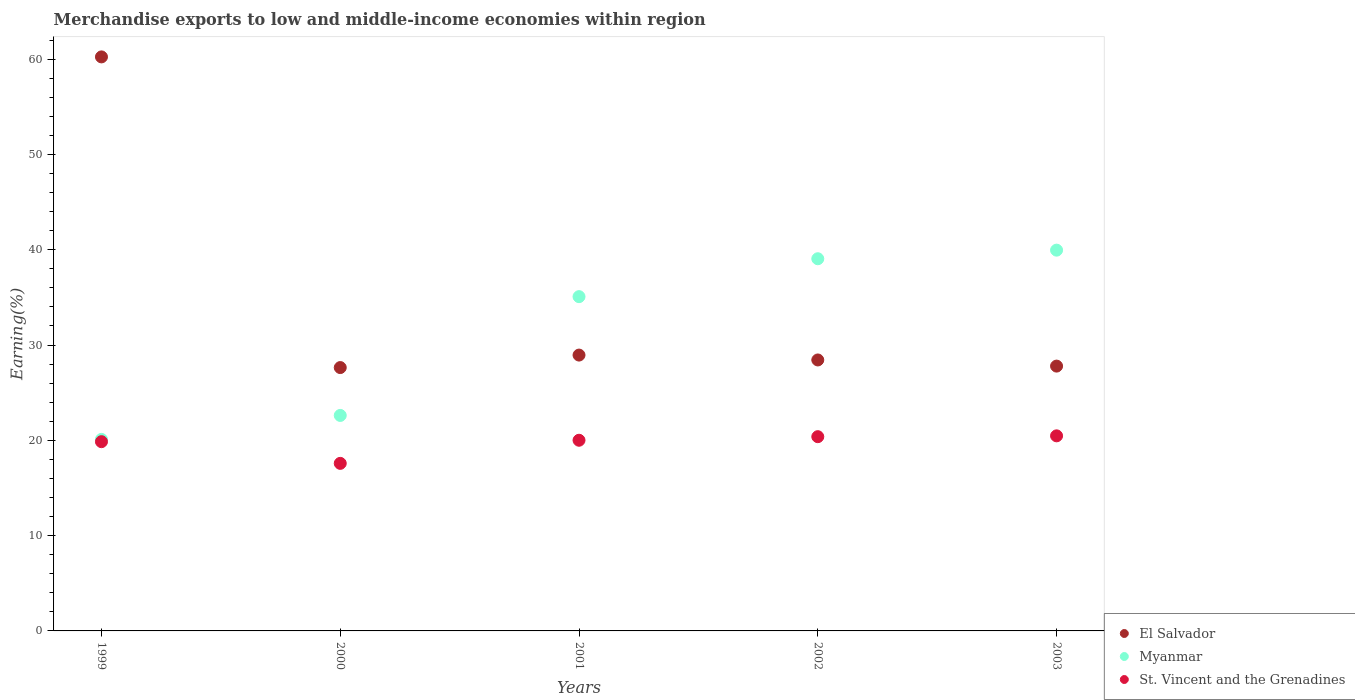Is the number of dotlines equal to the number of legend labels?
Give a very brief answer. Yes. What is the percentage of amount earned from merchandise exports in El Salvador in 1999?
Make the answer very short. 60.24. Across all years, what is the maximum percentage of amount earned from merchandise exports in St. Vincent and the Grenadines?
Offer a terse response. 20.47. Across all years, what is the minimum percentage of amount earned from merchandise exports in Myanmar?
Provide a succinct answer. 20.1. In which year was the percentage of amount earned from merchandise exports in St. Vincent and the Grenadines maximum?
Offer a very short reply. 2003. In which year was the percentage of amount earned from merchandise exports in El Salvador minimum?
Your answer should be compact. 2000. What is the total percentage of amount earned from merchandise exports in El Salvador in the graph?
Your answer should be very brief. 173.04. What is the difference between the percentage of amount earned from merchandise exports in St. Vincent and the Grenadines in 2001 and that in 2003?
Provide a short and direct response. -0.46. What is the difference between the percentage of amount earned from merchandise exports in Myanmar in 2002 and the percentage of amount earned from merchandise exports in St. Vincent and the Grenadines in 1999?
Keep it short and to the point. 19.2. What is the average percentage of amount earned from merchandise exports in Myanmar per year?
Your response must be concise. 31.36. In the year 2002, what is the difference between the percentage of amount earned from merchandise exports in St. Vincent and the Grenadines and percentage of amount earned from merchandise exports in El Salvador?
Offer a terse response. -8.05. In how many years, is the percentage of amount earned from merchandise exports in Myanmar greater than 58 %?
Offer a terse response. 0. What is the ratio of the percentage of amount earned from merchandise exports in El Salvador in 2000 to that in 2001?
Make the answer very short. 0.95. Is the percentage of amount earned from merchandise exports in El Salvador in 1999 less than that in 2002?
Provide a short and direct response. No. Is the difference between the percentage of amount earned from merchandise exports in St. Vincent and the Grenadines in 1999 and 2000 greater than the difference between the percentage of amount earned from merchandise exports in El Salvador in 1999 and 2000?
Offer a very short reply. No. What is the difference between the highest and the second highest percentage of amount earned from merchandise exports in El Salvador?
Provide a short and direct response. 31.29. What is the difference between the highest and the lowest percentage of amount earned from merchandise exports in Myanmar?
Provide a short and direct response. 19.86. In how many years, is the percentage of amount earned from merchandise exports in St. Vincent and the Grenadines greater than the average percentage of amount earned from merchandise exports in St. Vincent and the Grenadines taken over all years?
Provide a short and direct response. 4. Is the sum of the percentage of amount earned from merchandise exports in St. Vincent and the Grenadines in 1999 and 2002 greater than the maximum percentage of amount earned from merchandise exports in El Salvador across all years?
Provide a succinct answer. No. Is it the case that in every year, the sum of the percentage of amount earned from merchandise exports in Myanmar and percentage of amount earned from merchandise exports in St. Vincent and the Grenadines  is greater than the percentage of amount earned from merchandise exports in El Salvador?
Provide a short and direct response. No. Does the percentage of amount earned from merchandise exports in Myanmar monotonically increase over the years?
Ensure brevity in your answer.  Yes. Is the percentage of amount earned from merchandise exports in St. Vincent and the Grenadines strictly less than the percentage of amount earned from merchandise exports in Myanmar over the years?
Your response must be concise. Yes. How many dotlines are there?
Your answer should be very brief. 3. How many years are there in the graph?
Make the answer very short. 5. What is the difference between two consecutive major ticks on the Y-axis?
Ensure brevity in your answer.  10. Does the graph contain any zero values?
Offer a very short reply. No. How many legend labels are there?
Make the answer very short. 3. How are the legend labels stacked?
Your answer should be very brief. Vertical. What is the title of the graph?
Give a very brief answer. Merchandise exports to low and middle-income economies within region. Does "Uruguay" appear as one of the legend labels in the graph?
Your answer should be very brief. No. What is the label or title of the X-axis?
Your answer should be compact. Years. What is the label or title of the Y-axis?
Make the answer very short. Earning(%). What is the Earning(%) of El Salvador in 1999?
Provide a succinct answer. 60.24. What is the Earning(%) in Myanmar in 1999?
Offer a very short reply. 20.1. What is the Earning(%) of St. Vincent and the Grenadines in 1999?
Your response must be concise. 19.86. What is the Earning(%) of El Salvador in 2000?
Your answer should be very brief. 27.64. What is the Earning(%) in Myanmar in 2000?
Keep it short and to the point. 22.61. What is the Earning(%) of St. Vincent and the Grenadines in 2000?
Make the answer very short. 17.58. What is the Earning(%) of El Salvador in 2001?
Your answer should be very brief. 28.95. What is the Earning(%) in Myanmar in 2001?
Your response must be concise. 35.08. What is the Earning(%) of St. Vincent and the Grenadines in 2001?
Your answer should be compact. 20.01. What is the Earning(%) of El Salvador in 2002?
Your answer should be very brief. 28.43. What is the Earning(%) of Myanmar in 2002?
Your answer should be compact. 39.06. What is the Earning(%) in St. Vincent and the Grenadines in 2002?
Offer a terse response. 20.38. What is the Earning(%) of El Salvador in 2003?
Your answer should be compact. 27.79. What is the Earning(%) in Myanmar in 2003?
Make the answer very short. 39.96. What is the Earning(%) of St. Vincent and the Grenadines in 2003?
Give a very brief answer. 20.47. Across all years, what is the maximum Earning(%) of El Salvador?
Make the answer very short. 60.24. Across all years, what is the maximum Earning(%) of Myanmar?
Your response must be concise. 39.96. Across all years, what is the maximum Earning(%) of St. Vincent and the Grenadines?
Offer a terse response. 20.47. Across all years, what is the minimum Earning(%) in El Salvador?
Offer a terse response. 27.64. Across all years, what is the minimum Earning(%) of Myanmar?
Offer a terse response. 20.1. Across all years, what is the minimum Earning(%) in St. Vincent and the Grenadines?
Offer a very short reply. 17.58. What is the total Earning(%) in El Salvador in the graph?
Give a very brief answer. 173.04. What is the total Earning(%) of Myanmar in the graph?
Your answer should be very brief. 156.8. What is the total Earning(%) in St. Vincent and the Grenadines in the graph?
Keep it short and to the point. 98.3. What is the difference between the Earning(%) in El Salvador in 1999 and that in 2000?
Provide a short and direct response. 32.6. What is the difference between the Earning(%) of Myanmar in 1999 and that in 2000?
Give a very brief answer. -2.51. What is the difference between the Earning(%) in St. Vincent and the Grenadines in 1999 and that in 2000?
Provide a succinct answer. 2.27. What is the difference between the Earning(%) of El Salvador in 1999 and that in 2001?
Provide a succinct answer. 31.29. What is the difference between the Earning(%) of Myanmar in 1999 and that in 2001?
Your response must be concise. -14.98. What is the difference between the Earning(%) in St. Vincent and the Grenadines in 1999 and that in 2001?
Your response must be concise. -0.15. What is the difference between the Earning(%) in El Salvador in 1999 and that in 2002?
Offer a terse response. 31.8. What is the difference between the Earning(%) of Myanmar in 1999 and that in 2002?
Make the answer very short. -18.96. What is the difference between the Earning(%) of St. Vincent and the Grenadines in 1999 and that in 2002?
Your response must be concise. -0.53. What is the difference between the Earning(%) in El Salvador in 1999 and that in 2003?
Give a very brief answer. 32.45. What is the difference between the Earning(%) in Myanmar in 1999 and that in 2003?
Your answer should be compact. -19.86. What is the difference between the Earning(%) of St. Vincent and the Grenadines in 1999 and that in 2003?
Make the answer very short. -0.61. What is the difference between the Earning(%) in El Salvador in 2000 and that in 2001?
Ensure brevity in your answer.  -1.31. What is the difference between the Earning(%) of Myanmar in 2000 and that in 2001?
Provide a succinct answer. -12.47. What is the difference between the Earning(%) in St. Vincent and the Grenadines in 2000 and that in 2001?
Provide a succinct answer. -2.43. What is the difference between the Earning(%) of El Salvador in 2000 and that in 2002?
Give a very brief answer. -0.8. What is the difference between the Earning(%) in Myanmar in 2000 and that in 2002?
Give a very brief answer. -16.44. What is the difference between the Earning(%) in St. Vincent and the Grenadines in 2000 and that in 2002?
Keep it short and to the point. -2.8. What is the difference between the Earning(%) of El Salvador in 2000 and that in 2003?
Your answer should be very brief. -0.15. What is the difference between the Earning(%) in Myanmar in 2000 and that in 2003?
Your response must be concise. -17.34. What is the difference between the Earning(%) of St. Vincent and the Grenadines in 2000 and that in 2003?
Provide a short and direct response. -2.89. What is the difference between the Earning(%) of El Salvador in 2001 and that in 2002?
Keep it short and to the point. 0.51. What is the difference between the Earning(%) of Myanmar in 2001 and that in 2002?
Keep it short and to the point. -3.98. What is the difference between the Earning(%) in St. Vincent and the Grenadines in 2001 and that in 2002?
Offer a terse response. -0.37. What is the difference between the Earning(%) of El Salvador in 2001 and that in 2003?
Ensure brevity in your answer.  1.16. What is the difference between the Earning(%) of Myanmar in 2001 and that in 2003?
Offer a terse response. -4.88. What is the difference between the Earning(%) in St. Vincent and the Grenadines in 2001 and that in 2003?
Keep it short and to the point. -0.46. What is the difference between the Earning(%) in El Salvador in 2002 and that in 2003?
Your answer should be very brief. 0.64. What is the difference between the Earning(%) in Myanmar in 2002 and that in 2003?
Give a very brief answer. -0.9. What is the difference between the Earning(%) in St. Vincent and the Grenadines in 2002 and that in 2003?
Keep it short and to the point. -0.09. What is the difference between the Earning(%) of El Salvador in 1999 and the Earning(%) of Myanmar in 2000?
Provide a short and direct response. 37.62. What is the difference between the Earning(%) in El Salvador in 1999 and the Earning(%) in St. Vincent and the Grenadines in 2000?
Make the answer very short. 42.65. What is the difference between the Earning(%) in Myanmar in 1999 and the Earning(%) in St. Vincent and the Grenadines in 2000?
Offer a very short reply. 2.51. What is the difference between the Earning(%) of El Salvador in 1999 and the Earning(%) of Myanmar in 2001?
Ensure brevity in your answer.  25.16. What is the difference between the Earning(%) in El Salvador in 1999 and the Earning(%) in St. Vincent and the Grenadines in 2001?
Offer a terse response. 40.23. What is the difference between the Earning(%) in Myanmar in 1999 and the Earning(%) in St. Vincent and the Grenadines in 2001?
Your answer should be very brief. 0.09. What is the difference between the Earning(%) in El Salvador in 1999 and the Earning(%) in Myanmar in 2002?
Provide a short and direct response. 21.18. What is the difference between the Earning(%) of El Salvador in 1999 and the Earning(%) of St. Vincent and the Grenadines in 2002?
Your answer should be compact. 39.85. What is the difference between the Earning(%) of Myanmar in 1999 and the Earning(%) of St. Vincent and the Grenadines in 2002?
Offer a very short reply. -0.29. What is the difference between the Earning(%) of El Salvador in 1999 and the Earning(%) of Myanmar in 2003?
Provide a succinct answer. 20.28. What is the difference between the Earning(%) in El Salvador in 1999 and the Earning(%) in St. Vincent and the Grenadines in 2003?
Your response must be concise. 39.77. What is the difference between the Earning(%) in Myanmar in 1999 and the Earning(%) in St. Vincent and the Grenadines in 2003?
Give a very brief answer. -0.37. What is the difference between the Earning(%) in El Salvador in 2000 and the Earning(%) in Myanmar in 2001?
Ensure brevity in your answer.  -7.44. What is the difference between the Earning(%) of El Salvador in 2000 and the Earning(%) of St. Vincent and the Grenadines in 2001?
Give a very brief answer. 7.63. What is the difference between the Earning(%) in Myanmar in 2000 and the Earning(%) in St. Vincent and the Grenadines in 2001?
Your answer should be very brief. 2.6. What is the difference between the Earning(%) in El Salvador in 2000 and the Earning(%) in Myanmar in 2002?
Offer a terse response. -11.42. What is the difference between the Earning(%) of El Salvador in 2000 and the Earning(%) of St. Vincent and the Grenadines in 2002?
Your response must be concise. 7.25. What is the difference between the Earning(%) of Myanmar in 2000 and the Earning(%) of St. Vincent and the Grenadines in 2002?
Make the answer very short. 2.23. What is the difference between the Earning(%) in El Salvador in 2000 and the Earning(%) in Myanmar in 2003?
Make the answer very short. -12.32. What is the difference between the Earning(%) in El Salvador in 2000 and the Earning(%) in St. Vincent and the Grenadines in 2003?
Give a very brief answer. 7.16. What is the difference between the Earning(%) in Myanmar in 2000 and the Earning(%) in St. Vincent and the Grenadines in 2003?
Your response must be concise. 2.14. What is the difference between the Earning(%) in El Salvador in 2001 and the Earning(%) in Myanmar in 2002?
Your answer should be very brief. -10.11. What is the difference between the Earning(%) of El Salvador in 2001 and the Earning(%) of St. Vincent and the Grenadines in 2002?
Offer a very short reply. 8.56. What is the difference between the Earning(%) of Myanmar in 2001 and the Earning(%) of St. Vincent and the Grenadines in 2002?
Your answer should be compact. 14.69. What is the difference between the Earning(%) in El Salvador in 2001 and the Earning(%) in Myanmar in 2003?
Provide a short and direct response. -11.01. What is the difference between the Earning(%) of El Salvador in 2001 and the Earning(%) of St. Vincent and the Grenadines in 2003?
Provide a short and direct response. 8.47. What is the difference between the Earning(%) in Myanmar in 2001 and the Earning(%) in St. Vincent and the Grenadines in 2003?
Provide a succinct answer. 14.61. What is the difference between the Earning(%) in El Salvador in 2002 and the Earning(%) in Myanmar in 2003?
Provide a succinct answer. -11.52. What is the difference between the Earning(%) of El Salvador in 2002 and the Earning(%) of St. Vincent and the Grenadines in 2003?
Provide a short and direct response. 7.96. What is the difference between the Earning(%) of Myanmar in 2002 and the Earning(%) of St. Vincent and the Grenadines in 2003?
Offer a terse response. 18.58. What is the average Earning(%) of El Salvador per year?
Make the answer very short. 34.61. What is the average Earning(%) of Myanmar per year?
Make the answer very short. 31.36. What is the average Earning(%) in St. Vincent and the Grenadines per year?
Keep it short and to the point. 19.66. In the year 1999, what is the difference between the Earning(%) in El Salvador and Earning(%) in Myanmar?
Your answer should be very brief. 40.14. In the year 1999, what is the difference between the Earning(%) in El Salvador and Earning(%) in St. Vincent and the Grenadines?
Your answer should be very brief. 40.38. In the year 1999, what is the difference between the Earning(%) of Myanmar and Earning(%) of St. Vincent and the Grenadines?
Offer a very short reply. 0.24. In the year 2000, what is the difference between the Earning(%) in El Salvador and Earning(%) in Myanmar?
Your answer should be very brief. 5.02. In the year 2000, what is the difference between the Earning(%) of El Salvador and Earning(%) of St. Vincent and the Grenadines?
Provide a succinct answer. 10.05. In the year 2000, what is the difference between the Earning(%) of Myanmar and Earning(%) of St. Vincent and the Grenadines?
Give a very brief answer. 5.03. In the year 2001, what is the difference between the Earning(%) of El Salvador and Earning(%) of Myanmar?
Keep it short and to the point. -6.13. In the year 2001, what is the difference between the Earning(%) of El Salvador and Earning(%) of St. Vincent and the Grenadines?
Provide a short and direct response. 8.94. In the year 2001, what is the difference between the Earning(%) in Myanmar and Earning(%) in St. Vincent and the Grenadines?
Your answer should be very brief. 15.07. In the year 2002, what is the difference between the Earning(%) of El Salvador and Earning(%) of Myanmar?
Provide a succinct answer. -10.62. In the year 2002, what is the difference between the Earning(%) in El Salvador and Earning(%) in St. Vincent and the Grenadines?
Provide a succinct answer. 8.05. In the year 2002, what is the difference between the Earning(%) in Myanmar and Earning(%) in St. Vincent and the Grenadines?
Offer a terse response. 18.67. In the year 2003, what is the difference between the Earning(%) of El Salvador and Earning(%) of Myanmar?
Offer a very short reply. -12.17. In the year 2003, what is the difference between the Earning(%) in El Salvador and Earning(%) in St. Vincent and the Grenadines?
Your answer should be compact. 7.32. In the year 2003, what is the difference between the Earning(%) in Myanmar and Earning(%) in St. Vincent and the Grenadines?
Ensure brevity in your answer.  19.49. What is the ratio of the Earning(%) of El Salvador in 1999 to that in 2000?
Your answer should be compact. 2.18. What is the ratio of the Earning(%) in Myanmar in 1999 to that in 2000?
Offer a very short reply. 0.89. What is the ratio of the Earning(%) in St. Vincent and the Grenadines in 1999 to that in 2000?
Provide a succinct answer. 1.13. What is the ratio of the Earning(%) of El Salvador in 1999 to that in 2001?
Offer a very short reply. 2.08. What is the ratio of the Earning(%) in Myanmar in 1999 to that in 2001?
Ensure brevity in your answer.  0.57. What is the ratio of the Earning(%) in St. Vincent and the Grenadines in 1999 to that in 2001?
Offer a very short reply. 0.99. What is the ratio of the Earning(%) of El Salvador in 1999 to that in 2002?
Your response must be concise. 2.12. What is the ratio of the Earning(%) in Myanmar in 1999 to that in 2002?
Offer a very short reply. 0.51. What is the ratio of the Earning(%) in St. Vincent and the Grenadines in 1999 to that in 2002?
Make the answer very short. 0.97. What is the ratio of the Earning(%) of El Salvador in 1999 to that in 2003?
Give a very brief answer. 2.17. What is the ratio of the Earning(%) of Myanmar in 1999 to that in 2003?
Give a very brief answer. 0.5. What is the ratio of the Earning(%) of St. Vincent and the Grenadines in 1999 to that in 2003?
Provide a succinct answer. 0.97. What is the ratio of the Earning(%) in El Salvador in 2000 to that in 2001?
Your answer should be very brief. 0.95. What is the ratio of the Earning(%) of Myanmar in 2000 to that in 2001?
Give a very brief answer. 0.64. What is the ratio of the Earning(%) in St. Vincent and the Grenadines in 2000 to that in 2001?
Offer a very short reply. 0.88. What is the ratio of the Earning(%) in El Salvador in 2000 to that in 2002?
Provide a short and direct response. 0.97. What is the ratio of the Earning(%) in Myanmar in 2000 to that in 2002?
Your answer should be compact. 0.58. What is the ratio of the Earning(%) of St. Vincent and the Grenadines in 2000 to that in 2002?
Your answer should be compact. 0.86. What is the ratio of the Earning(%) in Myanmar in 2000 to that in 2003?
Provide a succinct answer. 0.57. What is the ratio of the Earning(%) in St. Vincent and the Grenadines in 2000 to that in 2003?
Your answer should be very brief. 0.86. What is the ratio of the Earning(%) of El Salvador in 2001 to that in 2002?
Your response must be concise. 1.02. What is the ratio of the Earning(%) in Myanmar in 2001 to that in 2002?
Your answer should be compact. 0.9. What is the ratio of the Earning(%) of St. Vincent and the Grenadines in 2001 to that in 2002?
Give a very brief answer. 0.98. What is the ratio of the Earning(%) of El Salvador in 2001 to that in 2003?
Offer a terse response. 1.04. What is the ratio of the Earning(%) in Myanmar in 2001 to that in 2003?
Provide a succinct answer. 0.88. What is the ratio of the Earning(%) of St. Vincent and the Grenadines in 2001 to that in 2003?
Offer a terse response. 0.98. What is the ratio of the Earning(%) in El Salvador in 2002 to that in 2003?
Offer a very short reply. 1.02. What is the ratio of the Earning(%) of Myanmar in 2002 to that in 2003?
Provide a short and direct response. 0.98. What is the ratio of the Earning(%) in St. Vincent and the Grenadines in 2002 to that in 2003?
Make the answer very short. 1. What is the difference between the highest and the second highest Earning(%) in El Salvador?
Keep it short and to the point. 31.29. What is the difference between the highest and the second highest Earning(%) in Myanmar?
Give a very brief answer. 0.9. What is the difference between the highest and the second highest Earning(%) in St. Vincent and the Grenadines?
Your response must be concise. 0.09. What is the difference between the highest and the lowest Earning(%) in El Salvador?
Your answer should be compact. 32.6. What is the difference between the highest and the lowest Earning(%) in Myanmar?
Your response must be concise. 19.86. What is the difference between the highest and the lowest Earning(%) of St. Vincent and the Grenadines?
Provide a succinct answer. 2.89. 